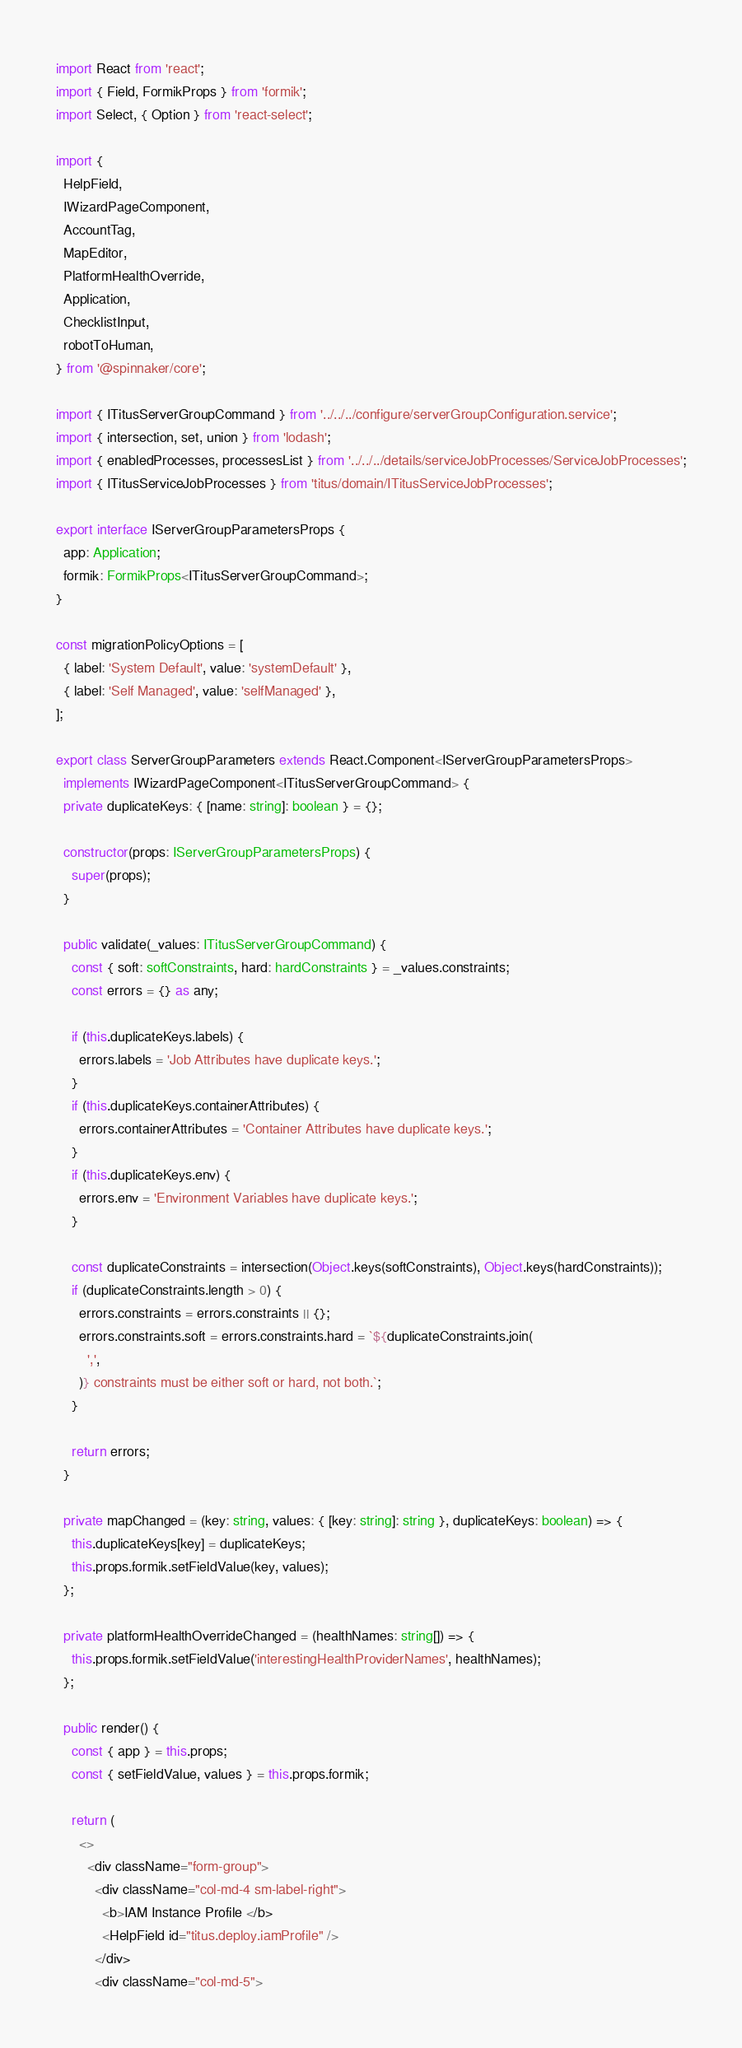<code> <loc_0><loc_0><loc_500><loc_500><_TypeScript_>import React from 'react';
import { Field, FormikProps } from 'formik';
import Select, { Option } from 'react-select';

import {
  HelpField,
  IWizardPageComponent,
  AccountTag,
  MapEditor,
  PlatformHealthOverride,
  Application,
  ChecklistInput,
  robotToHuman,
} from '@spinnaker/core';

import { ITitusServerGroupCommand } from '../../../configure/serverGroupConfiguration.service';
import { intersection, set, union } from 'lodash';
import { enabledProcesses, processesList } from '../../../details/serviceJobProcesses/ServiceJobProcesses';
import { ITitusServiceJobProcesses } from 'titus/domain/ITitusServiceJobProcesses';

export interface IServerGroupParametersProps {
  app: Application;
  formik: FormikProps<ITitusServerGroupCommand>;
}

const migrationPolicyOptions = [
  { label: 'System Default', value: 'systemDefault' },
  { label: 'Self Managed', value: 'selfManaged' },
];

export class ServerGroupParameters extends React.Component<IServerGroupParametersProps>
  implements IWizardPageComponent<ITitusServerGroupCommand> {
  private duplicateKeys: { [name: string]: boolean } = {};

  constructor(props: IServerGroupParametersProps) {
    super(props);
  }

  public validate(_values: ITitusServerGroupCommand) {
    const { soft: softConstraints, hard: hardConstraints } = _values.constraints;
    const errors = {} as any;

    if (this.duplicateKeys.labels) {
      errors.labels = 'Job Attributes have duplicate keys.';
    }
    if (this.duplicateKeys.containerAttributes) {
      errors.containerAttributes = 'Container Attributes have duplicate keys.';
    }
    if (this.duplicateKeys.env) {
      errors.env = 'Environment Variables have duplicate keys.';
    }

    const duplicateConstraints = intersection(Object.keys(softConstraints), Object.keys(hardConstraints));
    if (duplicateConstraints.length > 0) {
      errors.constraints = errors.constraints || {};
      errors.constraints.soft = errors.constraints.hard = `${duplicateConstraints.join(
        ',',
      )} constraints must be either soft or hard, not both.`;
    }

    return errors;
  }

  private mapChanged = (key: string, values: { [key: string]: string }, duplicateKeys: boolean) => {
    this.duplicateKeys[key] = duplicateKeys;
    this.props.formik.setFieldValue(key, values);
  };

  private platformHealthOverrideChanged = (healthNames: string[]) => {
    this.props.formik.setFieldValue('interestingHealthProviderNames', healthNames);
  };

  public render() {
    const { app } = this.props;
    const { setFieldValue, values } = this.props.formik;

    return (
      <>
        <div className="form-group">
          <div className="col-md-4 sm-label-right">
            <b>IAM Instance Profile </b>
            <HelpField id="titus.deploy.iamProfile" />
          </div>
          <div className="col-md-5"></code> 